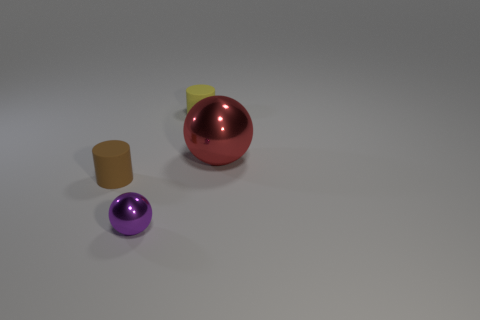Add 4 spheres. How many objects exist? 8 Subtract 0 blue cylinders. How many objects are left? 4 Subtract all tiny purple objects. Subtract all purple metal objects. How many objects are left? 2 Add 2 brown objects. How many brown objects are left? 3 Add 2 large green rubber cubes. How many large green rubber cubes exist? 2 